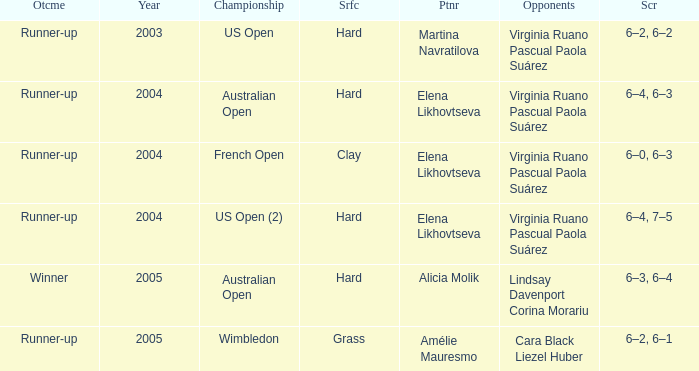When winner is the outcome what is the score? 6–3, 6–4. Could you parse the entire table? {'header': ['Otcme', 'Year', 'Championship', 'Srfc', 'Ptnr', 'Opponents', 'Scr'], 'rows': [['Runner-up', '2003', 'US Open', 'Hard', 'Martina Navratilova', 'Virginia Ruano Pascual Paola Suárez', '6–2, 6–2'], ['Runner-up', '2004', 'Australian Open', 'Hard', 'Elena Likhovtseva', 'Virginia Ruano Pascual Paola Suárez', '6–4, 6–3'], ['Runner-up', '2004', 'French Open', 'Clay', 'Elena Likhovtseva', 'Virginia Ruano Pascual Paola Suárez', '6–0, 6–3'], ['Runner-up', '2004', 'US Open (2)', 'Hard', 'Elena Likhovtseva', 'Virginia Ruano Pascual Paola Suárez', '6–4, 7–5'], ['Winner', '2005', 'Australian Open', 'Hard', 'Alicia Molik', 'Lindsay Davenport Corina Morariu', '6–3, 6–4'], ['Runner-up', '2005', 'Wimbledon', 'Grass', 'Amélie Mauresmo', 'Cara Black Liezel Huber', '6–2, 6–1']]} 